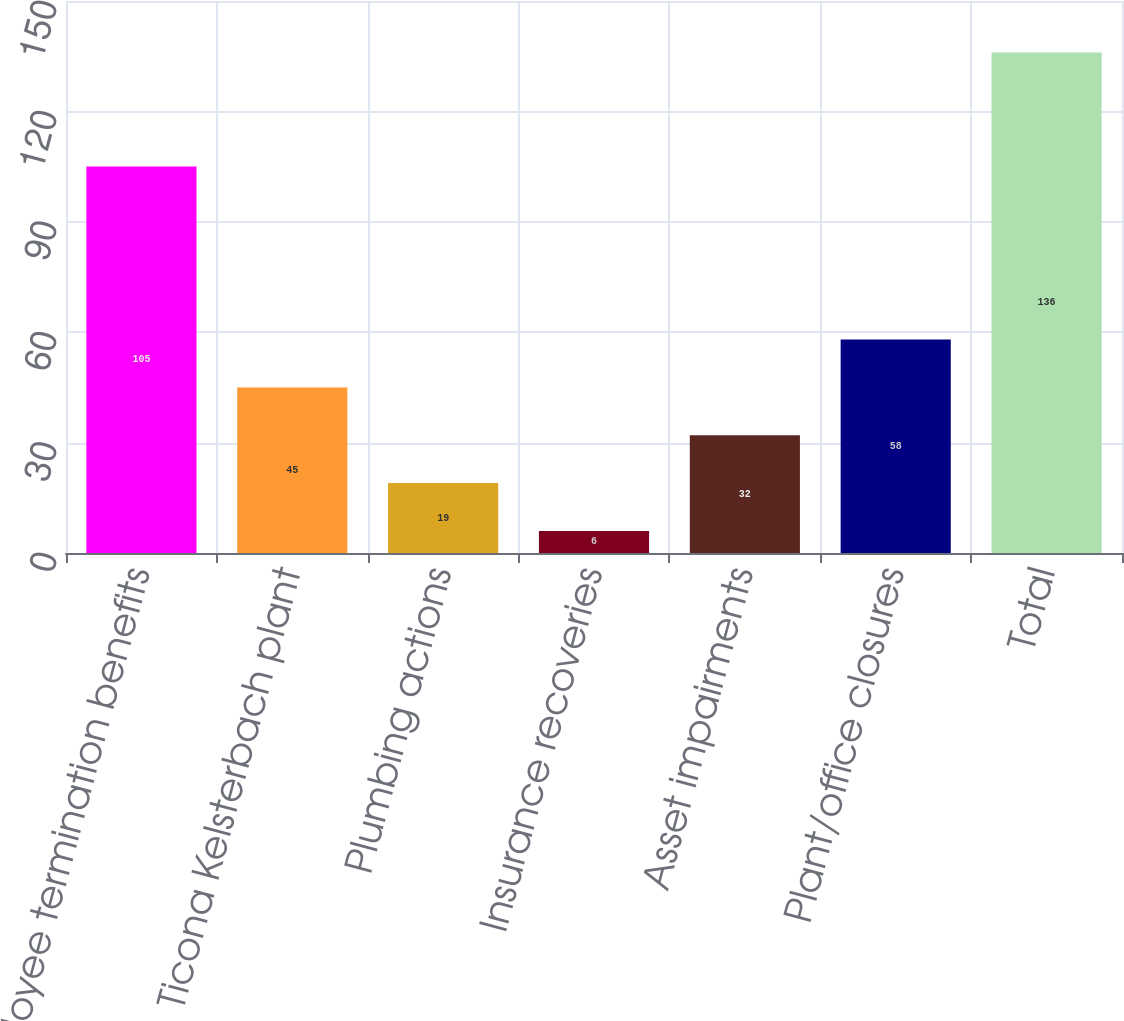Convert chart to OTSL. <chart><loc_0><loc_0><loc_500><loc_500><bar_chart><fcel>Employee termination benefits<fcel>Ticona Kelsterbach plant<fcel>Plumbing actions<fcel>Insurance recoveries<fcel>Asset impairments<fcel>Plant/office closures<fcel>Total<nl><fcel>105<fcel>45<fcel>19<fcel>6<fcel>32<fcel>58<fcel>136<nl></chart> 